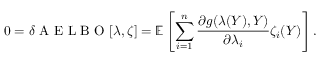Convert formula to latex. <formula><loc_0><loc_0><loc_500><loc_500>0 = \delta A E L B O [ \lambda , \zeta ] = \mathbb { E } \left [ \sum _ { i = 1 } ^ { n } \frac { \partial g ( \lambda ( Y ) , Y ) } { \partial \lambda _ { i } } \zeta _ { i } ( Y ) \right ] .</formula> 